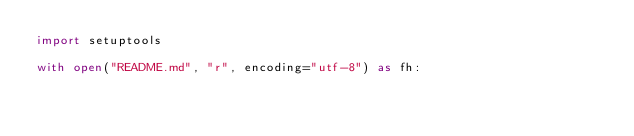<code> <loc_0><loc_0><loc_500><loc_500><_Python_>import setuptools

with open("README.md", "r", encoding="utf-8") as fh:</code> 